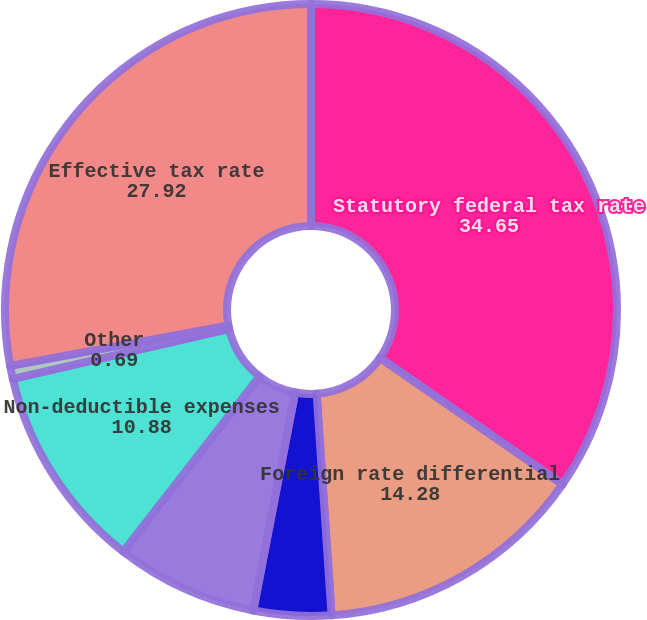<chart> <loc_0><loc_0><loc_500><loc_500><pie_chart><fcel>Statutory federal tax rate<fcel>Foreign rate differential<fcel>Federal and state income tax<fcel>State taxes<fcel>Non-deductible expenses<fcel>Other<fcel>Effective tax rate<nl><fcel>34.65%<fcel>14.28%<fcel>4.09%<fcel>7.49%<fcel>10.88%<fcel>0.69%<fcel>27.92%<nl></chart> 